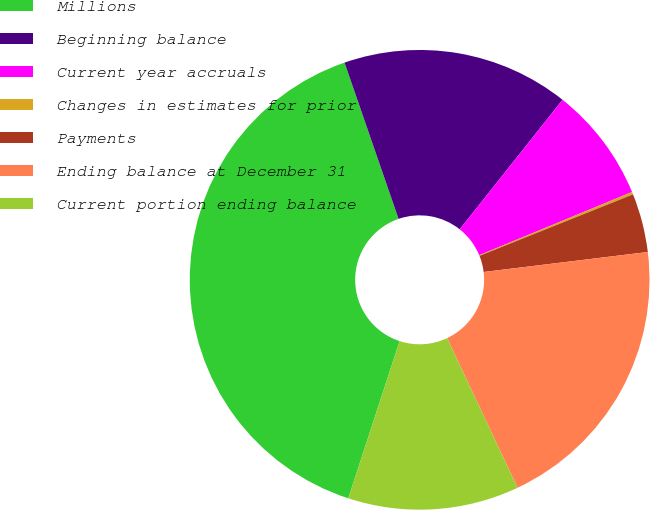Convert chart to OTSL. <chart><loc_0><loc_0><loc_500><loc_500><pie_chart><fcel>Millions<fcel>Beginning balance<fcel>Current year accruals<fcel>Changes in estimates for prior<fcel>Payments<fcel>Ending balance at December 31<fcel>Current portion ending balance<nl><fcel>39.68%<fcel>15.98%<fcel>8.08%<fcel>0.18%<fcel>4.13%<fcel>19.93%<fcel>12.03%<nl></chart> 